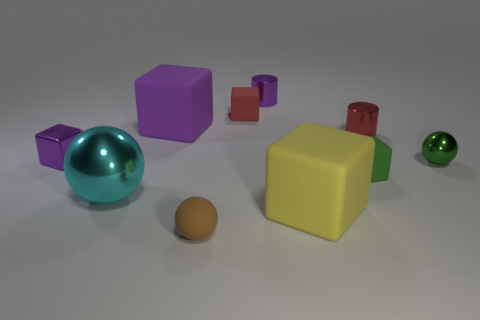Subtract all tiny green rubber cubes. How many cubes are left? 4 Subtract all balls. How many objects are left? 7 Subtract 2 balls. How many balls are left? 1 Subtract all purple cylinders. How many cylinders are left? 1 Add 7 small brown spheres. How many small brown spheres exist? 8 Subtract 0 yellow cylinders. How many objects are left? 10 Subtract all brown cylinders. Subtract all green spheres. How many cylinders are left? 2 Subtract all gray balls. How many yellow blocks are left? 1 Subtract all small brown things. Subtract all tiny rubber blocks. How many objects are left? 7 Add 6 small brown objects. How many small brown objects are left? 7 